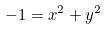<formula> <loc_0><loc_0><loc_500><loc_500>- 1 = x ^ { 2 } + y ^ { 2 }</formula> 